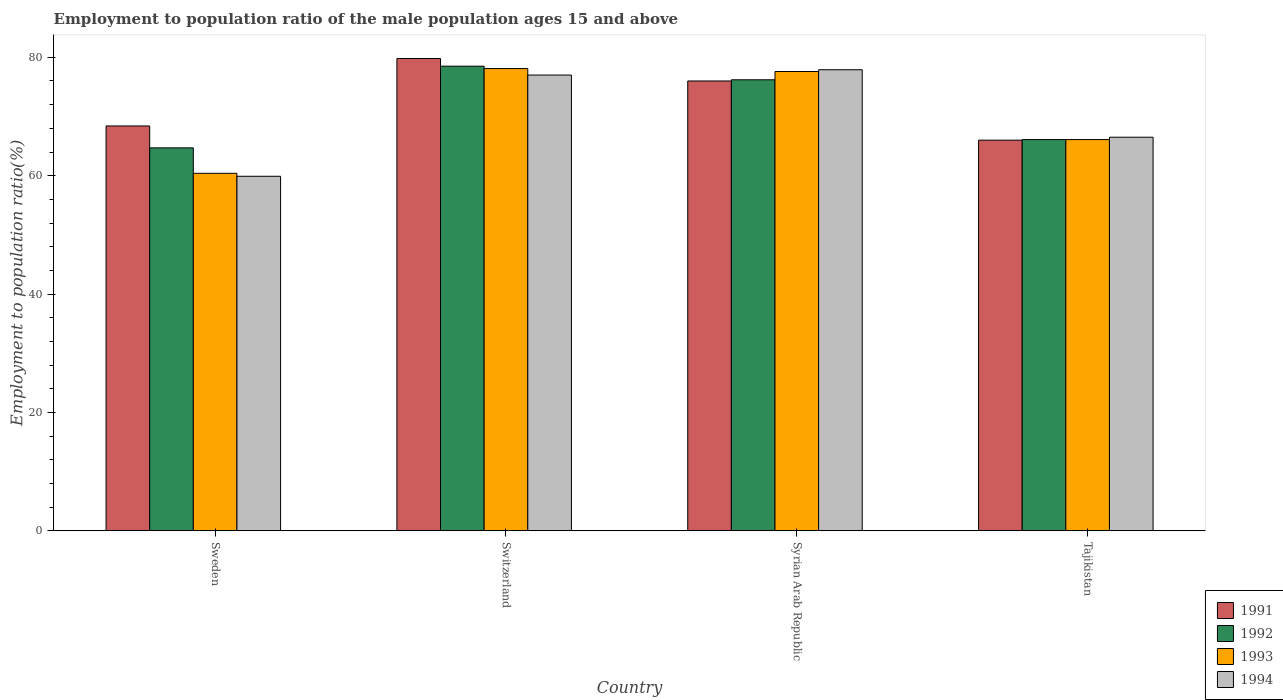How many different coloured bars are there?
Provide a succinct answer. 4. Are the number of bars per tick equal to the number of legend labels?
Keep it short and to the point. Yes. Are the number of bars on each tick of the X-axis equal?
Provide a short and direct response. Yes. What is the label of the 2nd group of bars from the left?
Your answer should be very brief. Switzerland. What is the employment to population ratio in 1992 in Syrian Arab Republic?
Ensure brevity in your answer.  76.2. Across all countries, what is the maximum employment to population ratio in 1991?
Keep it short and to the point. 79.8. Across all countries, what is the minimum employment to population ratio in 1994?
Keep it short and to the point. 59.9. In which country was the employment to population ratio in 1994 maximum?
Make the answer very short. Syrian Arab Republic. In which country was the employment to population ratio in 1991 minimum?
Your response must be concise. Tajikistan. What is the total employment to population ratio in 1992 in the graph?
Your response must be concise. 285.5. What is the difference between the employment to population ratio in 1992 in Sweden and that in Tajikistan?
Your answer should be compact. -1.4. What is the difference between the employment to population ratio in 1991 in Switzerland and the employment to population ratio in 1994 in Sweden?
Give a very brief answer. 19.9. What is the average employment to population ratio in 1991 per country?
Ensure brevity in your answer.  72.55. What is the difference between the employment to population ratio of/in 1991 and employment to population ratio of/in 1993 in Sweden?
Keep it short and to the point. 8. In how many countries, is the employment to population ratio in 1994 greater than 72 %?
Give a very brief answer. 2. What is the ratio of the employment to population ratio in 1994 in Sweden to that in Switzerland?
Your response must be concise. 0.78. Is the employment to population ratio in 1991 in Switzerland less than that in Tajikistan?
Make the answer very short. No. What is the difference between the highest and the second highest employment to population ratio in 1991?
Offer a very short reply. -7.6. What is the difference between the highest and the lowest employment to population ratio in 1991?
Give a very brief answer. 13.8. In how many countries, is the employment to population ratio in 1994 greater than the average employment to population ratio in 1994 taken over all countries?
Provide a succinct answer. 2. Is the sum of the employment to population ratio in 1994 in Sweden and Syrian Arab Republic greater than the maximum employment to population ratio in 1991 across all countries?
Make the answer very short. Yes. What does the 4th bar from the left in Tajikistan represents?
Provide a succinct answer. 1994. What does the 3rd bar from the right in Sweden represents?
Ensure brevity in your answer.  1992. What is the difference between two consecutive major ticks on the Y-axis?
Provide a short and direct response. 20. Are the values on the major ticks of Y-axis written in scientific E-notation?
Offer a very short reply. No. Does the graph contain any zero values?
Offer a very short reply. No. Where does the legend appear in the graph?
Provide a succinct answer. Bottom right. What is the title of the graph?
Provide a succinct answer. Employment to population ratio of the male population ages 15 and above. Does "1971" appear as one of the legend labels in the graph?
Make the answer very short. No. What is the Employment to population ratio(%) of 1991 in Sweden?
Give a very brief answer. 68.4. What is the Employment to population ratio(%) of 1992 in Sweden?
Keep it short and to the point. 64.7. What is the Employment to population ratio(%) of 1993 in Sweden?
Your answer should be compact. 60.4. What is the Employment to population ratio(%) in 1994 in Sweden?
Your answer should be compact. 59.9. What is the Employment to population ratio(%) in 1991 in Switzerland?
Your answer should be compact. 79.8. What is the Employment to population ratio(%) of 1992 in Switzerland?
Offer a terse response. 78.5. What is the Employment to population ratio(%) in 1993 in Switzerland?
Provide a short and direct response. 78.1. What is the Employment to population ratio(%) of 1992 in Syrian Arab Republic?
Ensure brevity in your answer.  76.2. What is the Employment to population ratio(%) in 1993 in Syrian Arab Republic?
Your answer should be compact. 77.6. What is the Employment to population ratio(%) in 1994 in Syrian Arab Republic?
Make the answer very short. 77.9. What is the Employment to population ratio(%) in 1991 in Tajikistan?
Your answer should be compact. 66. What is the Employment to population ratio(%) in 1992 in Tajikistan?
Your answer should be compact. 66.1. What is the Employment to population ratio(%) in 1993 in Tajikistan?
Provide a succinct answer. 66.1. What is the Employment to population ratio(%) in 1994 in Tajikistan?
Offer a terse response. 66.5. Across all countries, what is the maximum Employment to population ratio(%) in 1991?
Provide a short and direct response. 79.8. Across all countries, what is the maximum Employment to population ratio(%) in 1992?
Offer a very short reply. 78.5. Across all countries, what is the maximum Employment to population ratio(%) in 1993?
Give a very brief answer. 78.1. Across all countries, what is the maximum Employment to population ratio(%) in 1994?
Your response must be concise. 77.9. Across all countries, what is the minimum Employment to population ratio(%) in 1991?
Provide a succinct answer. 66. Across all countries, what is the minimum Employment to population ratio(%) in 1992?
Keep it short and to the point. 64.7. Across all countries, what is the minimum Employment to population ratio(%) in 1993?
Your response must be concise. 60.4. Across all countries, what is the minimum Employment to population ratio(%) of 1994?
Keep it short and to the point. 59.9. What is the total Employment to population ratio(%) of 1991 in the graph?
Ensure brevity in your answer.  290.2. What is the total Employment to population ratio(%) in 1992 in the graph?
Your answer should be very brief. 285.5. What is the total Employment to population ratio(%) of 1993 in the graph?
Provide a succinct answer. 282.2. What is the total Employment to population ratio(%) of 1994 in the graph?
Make the answer very short. 281.3. What is the difference between the Employment to population ratio(%) in 1991 in Sweden and that in Switzerland?
Your answer should be compact. -11.4. What is the difference between the Employment to population ratio(%) in 1992 in Sweden and that in Switzerland?
Give a very brief answer. -13.8. What is the difference between the Employment to population ratio(%) in 1993 in Sweden and that in Switzerland?
Offer a very short reply. -17.7. What is the difference between the Employment to population ratio(%) of 1994 in Sweden and that in Switzerland?
Offer a very short reply. -17.1. What is the difference between the Employment to population ratio(%) of 1992 in Sweden and that in Syrian Arab Republic?
Your answer should be compact. -11.5. What is the difference between the Employment to population ratio(%) of 1993 in Sweden and that in Syrian Arab Republic?
Offer a terse response. -17.2. What is the difference between the Employment to population ratio(%) in 1994 in Sweden and that in Syrian Arab Republic?
Your answer should be compact. -18. What is the difference between the Employment to population ratio(%) of 1994 in Sweden and that in Tajikistan?
Keep it short and to the point. -6.6. What is the difference between the Employment to population ratio(%) of 1993 in Switzerland and that in Syrian Arab Republic?
Your answer should be very brief. 0.5. What is the difference between the Employment to population ratio(%) of 1991 in Switzerland and that in Tajikistan?
Offer a very short reply. 13.8. What is the difference between the Employment to population ratio(%) in 1992 in Switzerland and that in Tajikistan?
Offer a terse response. 12.4. What is the difference between the Employment to population ratio(%) in 1992 in Syrian Arab Republic and that in Tajikistan?
Give a very brief answer. 10.1. What is the difference between the Employment to population ratio(%) in 1991 in Sweden and the Employment to population ratio(%) in 1992 in Switzerland?
Make the answer very short. -10.1. What is the difference between the Employment to population ratio(%) in 1991 in Sweden and the Employment to population ratio(%) in 1993 in Switzerland?
Provide a short and direct response. -9.7. What is the difference between the Employment to population ratio(%) in 1991 in Sweden and the Employment to population ratio(%) in 1994 in Switzerland?
Offer a very short reply. -8.6. What is the difference between the Employment to population ratio(%) in 1992 in Sweden and the Employment to population ratio(%) in 1994 in Switzerland?
Offer a terse response. -12.3. What is the difference between the Employment to population ratio(%) in 1993 in Sweden and the Employment to population ratio(%) in 1994 in Switzerland?
Provide a succinct answer. -16.6. What is the difference between the Employment to population ratio(%) in 1991 in Sweden and the Employment to population ratio(%) in 1993 in Syrian Arab Republic?
Your answer should be very brief. -9.2. What is the difference between the Employment to population ratio(%) in 1991 in Sweden and the Employment to population ratio(%) in 1994 in Syrian Arab Republic?
Your response must be concise. -9.5. What is the difference between the Employment to population ratio(%) in 1992 in Sweden and the Employment to population ratio(%) in 1994 in Syrian Arab Republic?
Offer a very short reply. -13.2. What is the difference between the Employment to population ratio(%) in 1993 in Sweden and the Employment to population ratio(%) in 1994 in Syrian Arab Republic?
Offer a terse response. -17.5. What is the difference between the Employment to population ratio(%) of 1991 in Sweden and the Employment to population ratio(%) of 1993 in Tajikistan?
Provide a succinct answer. 2.3. What is the difference between the Employment to population ratio(%) in 1992 in Sweden and the Employment to population ratio(%) in 1993 in Tajikistan?
Your answer should be very brief. -1.4. What is the difference between the Employment to population ratio(%) in 1993 in Sweden and the Employment to population ratio(%) in 1994 in Tajikistan?
Your response must be concise. -6.1. What is the difference between the Employment to population ratio(%) of 1991 in Switzerland and the Employment to population ratio(%) of 1994 in Syrian Arab Republic?
Your answer should be very brief. 1.9. What is the difference between the Employment to population ratio(%) of 1992 in Switzerland and the Employment to population ratio(%) of 1994 in Syrian Arab Republic?
Provide a short and direct response. 0.6. What is the difference between the Employment to population ratio(%) of 1993 in Switzerland and the Employment to population ratio(%) of 1994 in Syrian Arab Republic?
Your answer should be compact. 0.2. What is the difference between the Employment to population ratio(%) in 1991 in Switzerland and the Employment to population ratio(%) in 1994 in Tajikistan?
Give a very brief answer. 13.3. What is the difference between the Employment to population ratio(%) in 1991 in Syrian Arab Republic and the Employment to population ratio(%) in 1993 in Tajikistan?
Your answer should be compact. 9.9. What is the difference between the Employment to population ratio(%) of 1991 in Syrian Arab Republic and the Employment to population ratio(%) of 1994 in Tajikistan?
Your answer should be compact. 9.5. What is the difference between the Employment to population ratio(%) of 1992 in Syrian Arab Republic and the Employment to population ratio(%) of 1993 in Tajikistan?
Make the answer very short. 10.1. What is the average Employment to population ratio(%) of 1991 per country?
Your answer should be compact. 72.55. What is the average Employment to population ratio(%) of 1992 per country?
Your answer should be compact. 71.38. What is the average Employment to population ratio(%) in 1993 per country?
Your response must be concise. 70.55. What is the average Employment to population ratio(%) of 1994 per country?
Keep it short and to the point. 70.33. What is the difference between the Employment to population ratio(%) of 1991 and Employment to population ratio(%) of 1993 in Sweden?
Make the answer very short. 8. What is the difference between the Employment to population ratio(%) of 1991 and Employment to population ratio(%) of 1994 in Sweden?
Your answer should be compact. 8.5. What is the difference between the Employment to population ratio(%) of 1992 and Employment to population ratio(%) of 1994 in Sweden?
Offer a terse response. 4.8. What is the difference between the Employment to population ratio(%) in 1993 and Employment to population ratio(%) in 1994 in Sweden?
Keep it short and to the point. 0.5. What is the difference between the Employment to population ratio(%) of 1991 and Employment to population ratio(%) of 1992 in Switzerland?
Ensure brevity in your answer.  1.3. What is the difference between the Employment to population ratio(%) of 1991 and Employment to population ratio(%) of 1993 in Switzerland?
Make the answer very short. 1.7. What is the difference between the Employment to population ratio(%) in 1992 and Employment to population ratio(%) in 1994 in Switzerland?
Your answer should be compact. 1.5. What is the difference between the Employment to population ratio(%) of 1991 and Employment to population ratio(%) of 1993 in Syrian Arab Republic?
Provide a succinct answer. -1.6. What is the difference between the Employment to population ratio(%) of 1993 and Employment to population ratio(%) of 1994 in Syrian Arab Republic?
Make the answer very short. -0.3. What is the difference between the Employment to population ratio(%) of 1993 and Employment to population ratio(%) of 1994 in Tajikistan?
Keep it short and to the point. -0.4. What is the ratio of the Employment to population ratio(%) in 1992 in Sweden to that in Switzerland?
Your answer should be very brief. 0.82. What is the ratio of the Employment to population ratio(%) of 1993 in Sweden to that in Switzerland?
Provide a succinct answer. 0.77. What is the ratio of the Employment to population ratio(%) in 1994 in Sweden to that in Switzerland?
Provide a short and direct response. 0.78. What is the ratio of the Employment to population ratio(%) in 1992 in Sweden to that in Syrian Arab Republic?
Your answer should be compact. 0.85. What is the ratio of the Employment to population ratio(%) of 1993 in Sweden to that in Syrian Arab Republic?
Provide a short and direct response. 0.78. What is the ratio of the Employment to population ratio(%) in 1994 in Sweden to that in Syrian Arab Republic?
Give a very brief answer. 0.77. What is the ratio of the Employment to population ratio(%) of 1991 in Sweden to that in Tajikistan?
Your answer should be compact. 1.04. What is the ratio of the Employment to population ratio(%) in 1992 in Sweden to that in Tajikistan?
Your answer should be compact. 0.98. What is the ratio of the Employment to population ratio(%) of 1993 in Sweden to that in Tajikistan?
Your response must be concise. 0.91. What is the ratio of the Employment to population ratio(%) in 1994 in Sweden to that in Tajikistan?
Make the answer very short. 0.9. What is the ratio of the Employment to population ratio(%) of 1991 in Switzerland to that in Syrian Arab Republic?
Offer a very short reply. 1.05. What is the ratio of the Employment to population ratio(%) in 1992 in Switzerland to that in Syrian Arab Republic?
Offer a very short reply. 1.03. What is the ratio of the Employment to population ratio(%) of 1993 in Switzerland to that in Syrian Arab Republic?
Make the answer very short. 1.01. What is the ratio of the Employment to population ratio(%) of 1994 in Switzerland to that in Syrian Arab Republic?
Provide a succinct answer. 0.99. What is the ratio of the Employment to population ratio(%) of 1991 in Switzerland to that in Tajikistan?
Your response must be concise. 1.21. What is the ratio of the Employment to population ratio(%) of 1992 in Switzerland to that in Tajikistan?
Your answer should be compact. 1.19. What is the ratio of the Employment to population ratio(%) in 1993 in Switzerland to that in Tajikistan?
Provide a succinct answer. 1.18. What is the ratio of the Employment to population ratio(%) of 1994 in Switzerland to that in Tajikistan?
Your answer should be very brief. 1.16. What is the ratio of the Employment to population ratio(%) in 1991 in Syrian Arab Republic to that in Tajikistan?
Make the answer very short. 1.15. What is the ratio of the Employment to population ratio(%) of 1992 in Syrian Arab Republic to that in Tajikistan?
Your answer should be very brief. 1.15. What is the ratio of the Employment to population ratio(%) in 1993 in Syrian Arab Republic to that in Tajikistan?
Give a very brief answer. 1.17. What is the ratio of the Employment to population ratio(%) of 1994 in Syrian Arab Republic to that in Tajikistan?
Make the answer very short. 1.17. What is the difference between the highest and the second highest Employment to population ratio(%) of 1992?
Keep it short and to the point. 2.3. What is the difference between the highest and the second highest Employment to population ratio(%) of 1993?
Give a very brief answer. 0.5. What is the difference between the highest and the second highest Employment to population ratio(%) of 1994?
Your response must be concise. 0.9. 